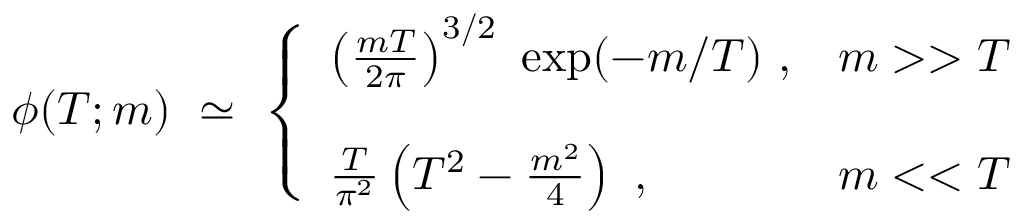Convert formula to latex. <formula><loc_0><loc_0><loc_500><loc_500>\phi ( T ; m ) \simeq \left \{ \begin{array} { l l } { { \left ( \frac { m T } { 2 \pi } \right ) ^ { 3 / 2 } \exp ( - m / T ) , } } & { m > > T } \\ { { \frac { T } { \pi ^ { 2 } } \left ( T ^ { 2 } - \frac { m ^ { 2 } } { 4 } \right ) , } } & { m < < T } \end{array}</formula> 